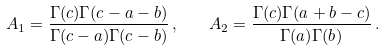<formula> <loc_0><loc_0><loc_500><loc_500>A _ { 1 } = { \frac { \Gamma ( c ) \Gamma ( c - a - b ) } { \Gamma ( c - a ) \Gamma ( c - b ) } } \, , \quad A _ { 2 } = { \frac { \Gamma ( c ) \Gamma ( a + b - c ) } { \Gamma ( a ) \Gamma ( b ) } } \, .</formula> 